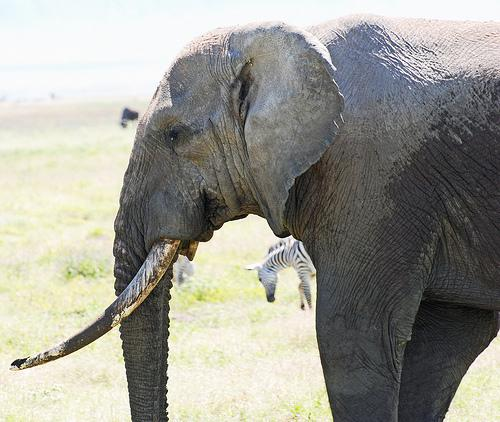For a referential expression grounding task, describe the location of the ear of the elephant in relation to the other animals in the image. The ear of the elephant is located towards the front of the image, with the zebra and buffalo being in the background behind it. Provide a brief description of the elephant's appearance, including any distinct features or characteristics. The elephant is grey and has small ears, tusks with mud, and wrinkly wet skin. The species is likely an African elephant. In a multi-choice VQA context, which of the following adjectives best describes the elephant's size: tiny, huge, or average?  Huge What specific details about the elephant's tusks are mentioned in the provided information? The elephant's tusks are white, but they also have mud on them, making them appear dirty. In the context of a product advertisement, what possible product could be sold using this image? This image could be used for advertising a wildlife safari tour, showcasing the close encounters with animals like elephants, zebras, and buffaloes in their natural habitat. What is the primary focus of this image and its features? The primary focus of this image is a large grey elephant with small ears, wrinkly skin, and tusks with mud, standing in the wild with a zebra grazing behind it. Choose one of the animals not being the elephant, and describe its appearance and location. A zebra is seen behind the elephant, with black and white stripes on its body, eating some grass. Based on the information provided, can you explain if the weather is good or bad in the image and why? The weather appears to be good in the image, as it's described as sunny, with the sun shining on the elephants back. Can you explain the setting that these animals are in, including any environmental characteristics? These wild animals are in an African safari setting, with sparse patches of brown grass and a sunny atmosphere. What types of animals are in this image, and where are they located? There is an elephant in the foreground and a zebra grazing behind it. A buffalo can be seen in the background as well. 